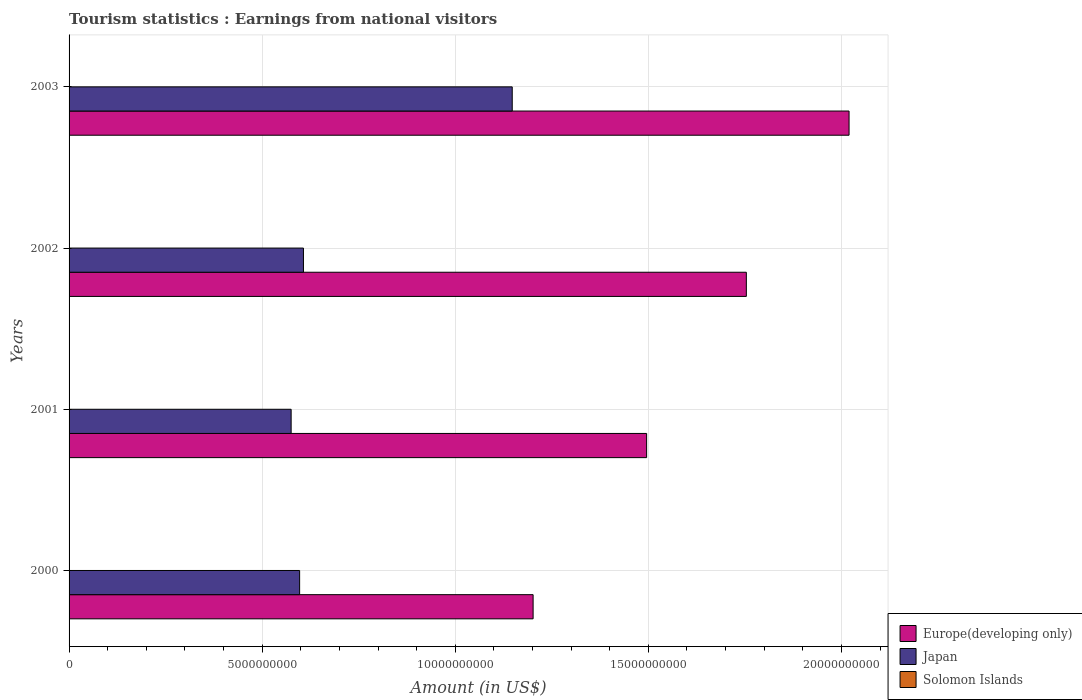How many different coloured bars are there?
Your answer should be compact. 3. Are the number of bars per tick equal to the number of legend labels?
Provide a succinct answer. Yes. How many bars are there on the 3rd tick from the top?
Your answer should be compact. 3. What is the label of the 2nd group of bars from the top?
Keep it short and to the point. 2002. In how many cases, is the number of bars for a given year not equal to the number of legend labels?
Your answer should be compact. 0. What is the earnings from national visitors in Japan in 2001?
Your response must be concise. 5.75e+09. Across all years, what is the maximum earnings from national visitors in Solomon Islands?
Ensure brevity in your answer.  8.80e+06. Across all years, what is the minimum earnings from national visitors in Solomon Islands?
Offer a very short reply. 8.00e+05. What is the total earnings from national visitors in Japan in the graph?
Your response must be concise. 2.93e+1. What is the difference between the earnings from national visitors in Japan in 2002 and that in 2003?
Ensure brevity in your answer.  -5.41e+09. What is the difference between the earnings from national visitors in Japan in 2000 and the earnings from national visitors in Europe(developing only) in 2002?
Offer a terse response. -1.16e+1. What is the average earnings from national visitors in Japan per year?
Give a very brief answer. 7.32e+09. In the year 2003, what is the difference between the earnings from national visitors in Solomon Islands and earnings from national visitors in Europe(developing only)?
Offer a terse response. -2.02e+1. In how many years, is the earnings from national visitors in Solomon Islands greater than 19000000000 US$?
Offer a terse response. 0. What is the ratio of the earnings from national visitors in Japan in 2002 to that in 2003?
Provide a succinct answer. 0.53. Is the difference between the earnings from national visitors in Solomon Islands in 2001 and 2002 greater than the difference between the earnings from national visitors in Europe(developing only) in 2001 and 2002?
Keep it short and to the point. Yes. What is the difference between the highest and the second highest earnings from national visitors in Europe(developing only)?
Provide a short and direct response. 2.66e+09. What is the difference between the highest and the lowest earnings from national visitors in Europe(developing only)?
Provide a succinct answer. 8.18e+09. Is the sum of the earnings from national visitors in Europe(developing only) in 2001 and 2002 greater than the maximum earnings from national visitors in Solomon Islands across all years?
Your answer should be compact. Yes. What does the 3rd bar from the top in 2001 represents?
Provide a succinct answer. Europe(developing only). What does the 3rd bar from the bottom in 2001 represents?
Your answer should be compact. Solomon Islands. Is it the case that in every year, the sum of the earnings from national visitors in Japan and earnings from national visitors in Europe(developing only) is greater than the earnings from national visitors in Solomon Islands?
Keep it short and to the point. Yes. How many bars are there?
Provide a succinct answer. 12. Are all the bars in the graph horizontal?
Your answer should be compact. Yes. How many years are there in the graph?
Keep it short and to the point. 4. What is the difference between two consecutive major ticks on the X-axis?
Your answer should be compact. 5.00e+09. Are the values on the major ticks of X-axis written in scientific E-notation?
Your response must be concise. No. Does the graph contain grids?
Offer a very short reply. Yes. Where does the legend appear in the graph?
Your response must be concise. Bottom right. How many legend labels are there?
Make the answer very short. 3. What is the title of the graph?
Make the answer very short. Tourism statistics : Earnings from national visitors. Does "Middle East & North Africa (developing only)" appear as one of the legend labels in the graph?
Provide a succinct answer. No. What is the Amount (in US$) in Europe(developing only) in 2000?
Provide a succinct answer. 1.20e+1. What is the Amount (in US$) in Japan in 2000?
Provide a succinct answer. 5.97e+09. What is the Amount (in US$) in Europe(developing only) in 2001?
Make the answer very short. 1.50e+1. What is the Amount (in US$) in Japan in 2001?
Give a very brief answer. 5.75e+09. What is the Amount (in US$) in Solomon Islands in 2001?
Provide a succinct answer. 8.80e+06. What is the Amount (in US$) of Europe(developing only) in 2002?
Ensure brevity in your answer.  1.75e+1. What is the Amount (in US$) in Japan in 2002?
Your answer should be very brief. 6.07e+09. What is the Amount (in US$) in Europe(developing only) in 2003?
Provide a succinct answer. 2.02e+1. What is the Amount (in US$) of Japan in 2003?
Your answer should be very brief. 1.15e+1. What is the Amount (in US$) in Solomon Islands in 2003?
Provide a succinct answer. 1.60e+06. Across all years, what is the maximum Amount (in US$) in Europe(developing only)?
Your response must be concise. 2.02e+1. Across all years, what is the maximum Amount (in US$) of Japan?
Offer a terse response. 1.15e+1. Across all years, what is the maximum Amount (in US$) in Solomon Islands?
Keep it short and to the point. 8.80e+06. Across all years, what is the minimum Amount (in US$) of Europe(developing only)?
Make the answer very short. 1.20e+1. Across all years, what is the minimum Amount (in US$) of Japan?
Your response must be concise. 5.75e+09. Across all years, what is the minimum Amount (in US$) of Solomon Islands?
Provide a succinct answer. 8.00e+05. What is the total Amount (in US$) of Europe(developing only) in the graph?
Ensure brevity in your answer.  6.47e+1. What is the total Amount (in US$) of Japan in the graph?
Your answer should be very brief. 2.93e+1. What is the total Amount (in US$) in Solomon Islands in the graph?
Give a very brief answer. 1.52e+07. What is the difference between the Amount (in US$) in Europe(developing only) in 2000 and that in 2001?
Your answer should be very brief. -2.94e+09. What is the difference between the Amount (in US$) of Japan in 2000 and that in 2001?
Make the answer very short. 2.20e+08. What is the difference between the Amount (in US$) of Solomon Islands in 2000 and that in 2001?
Make the answer very short. -4.80e+06. What is the difference between the Amount (in US$) in Europe(developing only) in 2000 and that in 2002?
Offer a very short reply. -5.52e+09. What is the difference between the Amount (in US$) in Japan in 2000 and that in 2002?
Make the answer very short. -9.90e+07. What is the difference between the Amount (in US$) of Solomon Islands in 2000 and that in 2002?
Give a very brief answer. 3.20e+06. What is the difference between the Amount (in US$) of Europe(developing only) in 2000 and that in 2003?
Provide a short and direct response. -8.18e+09. What is the difference between the Amount (in US$) of Japan in 2000 and that in 2003?
Make the answer very short. -5.50e+09. What is the difference between the Amount (in US$) in Solomon Islands in 2000 and that in 2003?
Make the answer very short. 2.40e+06. What is the difference between the Amount (in US$) of Europe(developing only) in 2001 and that in 2002?
Provide a short and direct response. -2.58e+09. What is the difference between the Amount (in US$) of Japan in 2001 and that in 2002?
Offer a terse response. -3.19e+08. What is the difference between the Amount (in US$) of Solomon Islands in 2001 and that in 2002?
Your response must be concise. 8.00e+06. What is the difference between the Amount (in US$) of Europe(developing only) in 2001 and that in 2003?
Offer a very short reply. -5.24e+09. What is the difference between the Amount (in US$) in Japan in 2001 and that in 2003?
Provide a short and direct response. -5.72e+09. What is the difference between the Amount (in US$) in Solomon Islands in 2001 and that in 2003?
Keep it short and to the point. 7.20e+06. What is the difference between the Amount (in US$) of Europe(developing only) in 2002 and that in 2003?
Your answer should be very brief. -2.66e+09. What is the difference between the Amount (in US$) in Japan in 2002 and that in 2003?
Give a very brief answer. -5.41e+09. What is the difference between the Amount (in US$) in Solomon Islands in 2002 and that in 2003?
Give a very brief answer. -8.00e+05. What is the difference between the Amount (in US$) in Europe(developing only) in 2000 and the Amount (in US$) in Japan in 2001?
Your answer should be very brief. 6.27e+09. What is the difference between the Amount (in US$) of Europe(developing only) in 2000 and the Amount (in US$) of Solomon Islands in 2001?
Give a very brief answer. 1.20e+1. What is the difference between the Amount (in US$) in Japan in 2000 and the Amount (in US$) in Solomon Islands in 2001?
Offer a terse response. 5.96e+09. What is the difference between the Amount (in US$) in Europe(developing only) in 2000 and the Amount (in US$) in Japan in 2002?
Your answer should be very brief. 5.95e+09. What is the difference between the Amount (in US$) in Europe(developing only) in 2000 and the Amount (in US$) in Solomon Islands in 2002?
Provide a short and direct response. 1.20e+1. What is the difference between the Amount (in US$) of Japan in 2000 and the Amount (in US$) of Solomon Islands in 2002?
Your answer should be very brief. 5.97e+09. What is the difference between the Amount (in US$) of Europe(developing only) in 2000 and the Amount (in US$) of Japan in 2003?
Your response must be concise. 5.41e+08. What is the difference between the Amount (in US$) of Europe(developing only) in 2000 and the Amount (in US$) of Solomon Islands in 2003?
Provide a succinct answer. 1.20e+1. What is the difference between the Amount (in US$) in Japan in 2000 and the Amount (in US$) in Solomon Islands in 2003?
Make the answer very short. 5.97e+09. What is the difference between the Amount (in US$) of Europe(developing only) in 2001 and the Amount (in US$) of Japan in 2002?
Offer a very short reply. 8.89e+09. What is the difference between the Amount (in US$) of Europe(developing only) in 2001 and the Amount (in US$) of Solomon Islands in 2002?
Ensure brevity in your answer.  1.50e+1. What is the difference between the Amount (in US$) in Japan in 2001 and the Amount (in US$) in Solomon Islands in 2002?
Keep it short and to the point. 5.75e+09. What is the difference between the Amount (in US$) of Europe(developing only) in 2001 and the Amount (in US$) of Japan in 2003?
Ensure brevity in your answer.  3.48e+09. What is the difference between the Amount (in US$) in Europe(developing only) in 2001 and the Amount (in US$) in Solomon Islands in 2003?
Offer a very short reply. 1.50e+1. What is the difference between the Amount (in US$) of Japan in 2001 and the Amount (in US$) of Solomon Islands in 2003?
Offer a terse response. 5.75e+09. What is the difference between the Amount (in US$) in Europe(developing only) in 2002 and the Amount (in US$) in Japan in 2003?
Offer a terse response. 6.06e+09. What is the difference between the Amount (in US$) in Europe(developing only) in 2002 and the Amount (in US$) in Solomon Islands in 2003?
Keep it short and to the point. 1.75e+1. What is the difference between the Amount (in US$) of Japan in 2002 and the Amount (in US$) of Solomon Islands in 2003?
Give a very brief answer. 6.07e+09. What is the average Amount (in US$) in Europe(developing only) per year?
Your answer should be very brief. 1.62e+1. What is the average Amount (in US$) of Japan per year?
Offer a terse response. 7.32e+09. What is the average Amount (in US$) in Solomon Islands per year?
Your response must be concise. 3.80e+06. In the year 2000, what is the difference between the Amount (in US$) in Europe(developing only) and Amount (in US$) in Japan?
Your answer should be compact. 6.05e+09. In the year 2000, what is the difference between the Amount (in US$) of Europe(developing only) and Amount (in US$) of Solomon Islands?
Provide a short and direct response. 1.20e+1. In the year 2000, what is the difference between the Amount (in US$) in Japan and Amount (in US$) in Solomon Islands?
Make the answer very short. 5.97e+09. In the year 2001, what is the difference between the Amount (in US$) of Europe(developing only) and Amount (in US$) of Japan?
Give a very brief answer. 9.20e+09. In the year 2001, what is the difference between the Amount (in US$) in Europe(developing only) and Amount (in US$) in Solomon Islands?
Your answer should be compact. 1.49e+1. In the year 2001, what is the difference between the Amount (in US$) in Japan and Amount (in US$) in Solomon Islands?
Offer a very short reply. 5.74e+09. In the year 2002, what is the difference between the Amount (in US$) of Europe(developing only) and Amount (in US$) of Japan?
Make the answer very short. 1.15e+1. In the year 2002, what is the difference between the Amount (in US$) in Europe(developing only) and Amount (in US$) in Solomon Islands?
Your answer should be compact. 1.75e+1. In the year 2002, what is the difference between the Amount (in US$) in Japan and Amount (in US$) in Solomon Islands?
Your response must be concise. 6.07e+09. In the year 2003, what is the difference between the Amount (in US$) in Europe(developing only) and Amount (in US$) in Japan?
Your answer should be very brief. 8.72e+09. In the year 2003, what is the difference between the Amount (in US$) in Europe(developing only) and Amount (in US$) in Solomon Islands?
Provide a short and direct response. 2.02e+1. In the year 2003, what is the difference between the Amount (in US$) of Japan and Amount (in US$) of Solomon Islands?
Make the answer very short. 1.15e+1. What is the ratio of the Amount (in US$) of Europe(developing only) in 2000 to that in 2001?
Make the answer very short. 0.8. What is the ratio of the Amount (in US$) in Japan in 2000 to that in 2001?
Your response must be concise. 1.04. What is the ratio of the Amount (in US$) of Solomon Islands in 2000 to that in 2001?
Your response must be concise. 0.45. What is the ratio of the Amount (in US$) in Europe(developing only) in 2000 to that in 2002?
Provide a short and direct response. 0.69. What is the ratio of the Amount (in US$) in Japan in 2000 to that in 2002?
Provide a succinct answer. 0.98. What is the ratio of the Amount (in US$) of Europe(developing only) in 2000 to that in 2003?
Your answer should be very brief. 0.59. What is the ratio of the Amount (in US$) in Japan in 2000 to that in 2003?
Give a very brief answer. 0.52. What is the ratio of the Amount (in US$) of Solomon Islands in 2000 to that in 2003?
Your answer should be very brief. 2.5. What is the ratio of the Amount (in US$) of Europe(developing only) in 2001 to that in 2002?
Your response must be concise. 0.85. What is the ratio of the Amount (in US$) in Japan in 2001 to that in 2002?
Make the answer very short. 0.95. What is the ratio of the Amount (in US$) in Europe(developing only) in 2001 to that in 2003?
Give a very brief answer. 0.74. What is the ratio of the Amount (in US$) in Japan in 2001 to that in 2003?
Ensure brevity in your answer.  0.5. What is the ratio of the Amount (in US$) of Solomon Islands in 2001 to that in 2003?
Your answer should be very brief. 5.5. What is the ratio of the Amount (in US$) of Europe(developing only) in 2002 to that in 2003?
Provide a short and direct response. 0.87. What is the ratio of the Amount (in US$) of Japan in 2002 to that in 2003?
Your answer should be compact. 0.53. What is the difference between the highest and the second highest Amount (in US$) in Europe(developing only)?
Make the answer very short. 2.66e+09. What is the difference between the highest and the second highest Amount (in US$) in Japan?
Provide a succinct answer. 5.41e+09. What is the difference between the highest and the second highest Amount (in US$) in Solomon Islands?
Provide a short and direct response. 4.80e+06. What is the difference between the highest and the lowest Amount (in US$) of Europe(developing only)?
Your answer should be compact. 8.18e+09. What is the difference between the highest and the lowest Amount (in US$) of Japan?
Provide a succinct answer. 5.72e+09. 